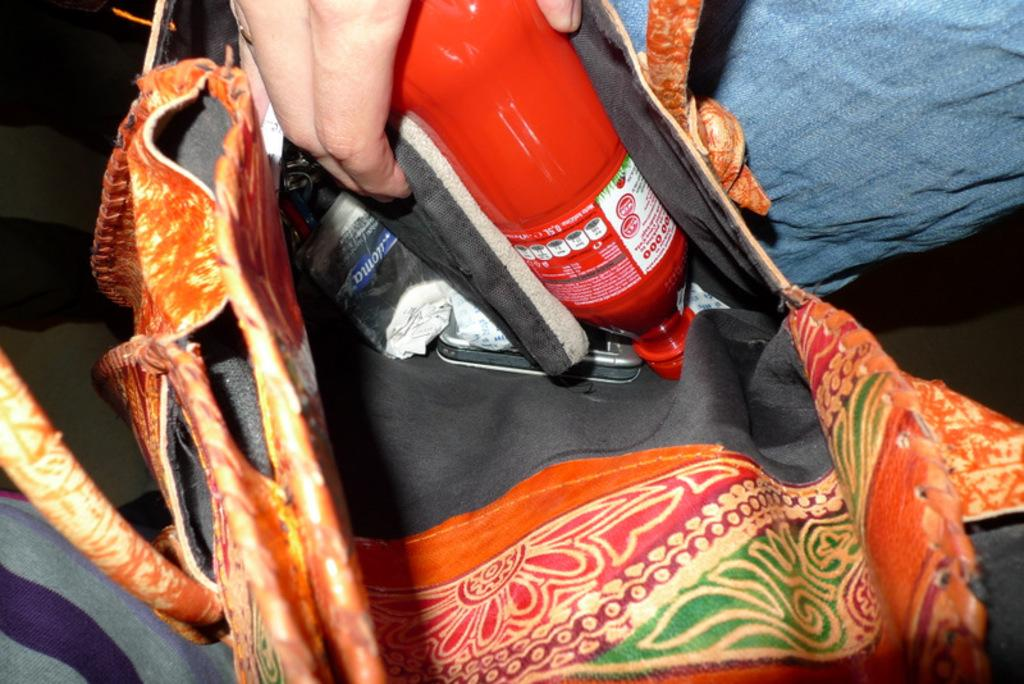Who is present in the image? There is a person in the image. What is the person holding in the image? The person is holding a bag and a juice bottle in his hand. What type of dog is tied to the person's leg in the image? There is no dog present in the image. What color is the string that the person is using to fly a kite in the image? There is no string or kite present in the image. 